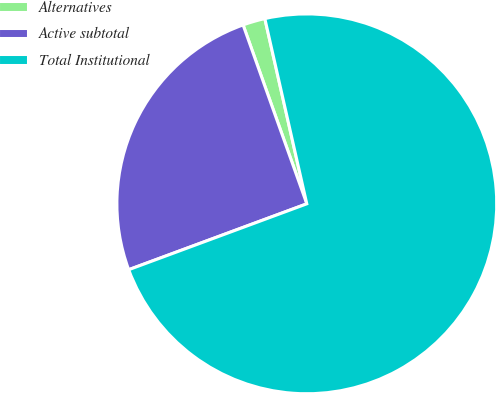<chart> <loc_0><loc_0><loc_500><loc_500><pie_chart><fcel>Alternatives<fcel>Active subtotal<fcel>Total Institutional<nl><fcel>1.9%<fcel>25.19%<fcel>72.9%<nl></chart> 